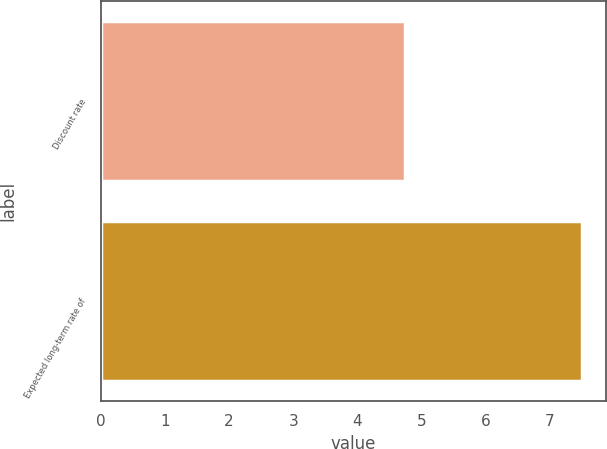Convert chart to OTSL. <chart><loc_0><loc_0><loc_500><loc_500><bar_chart><fcel>Discount rate<fcel>Expected long-term rate of<nl><fcel>4.75<fcel>7.5<nl></chart> 